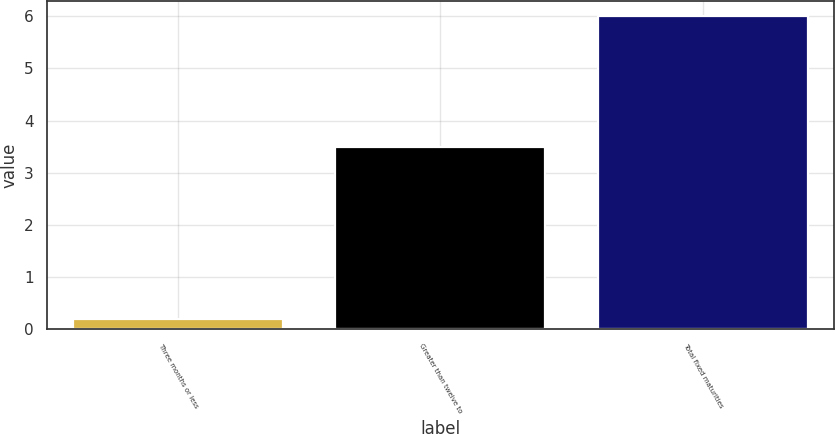<chart> <loc_0><loc_0><loc_500><loc_500><bar_chart><fcel>Three months or less<fcel>Greater than twelve to<fcel>Total fixed maturities<nl><fcel>0.2<fcel>3.5<fcel>6<nl></chart> 